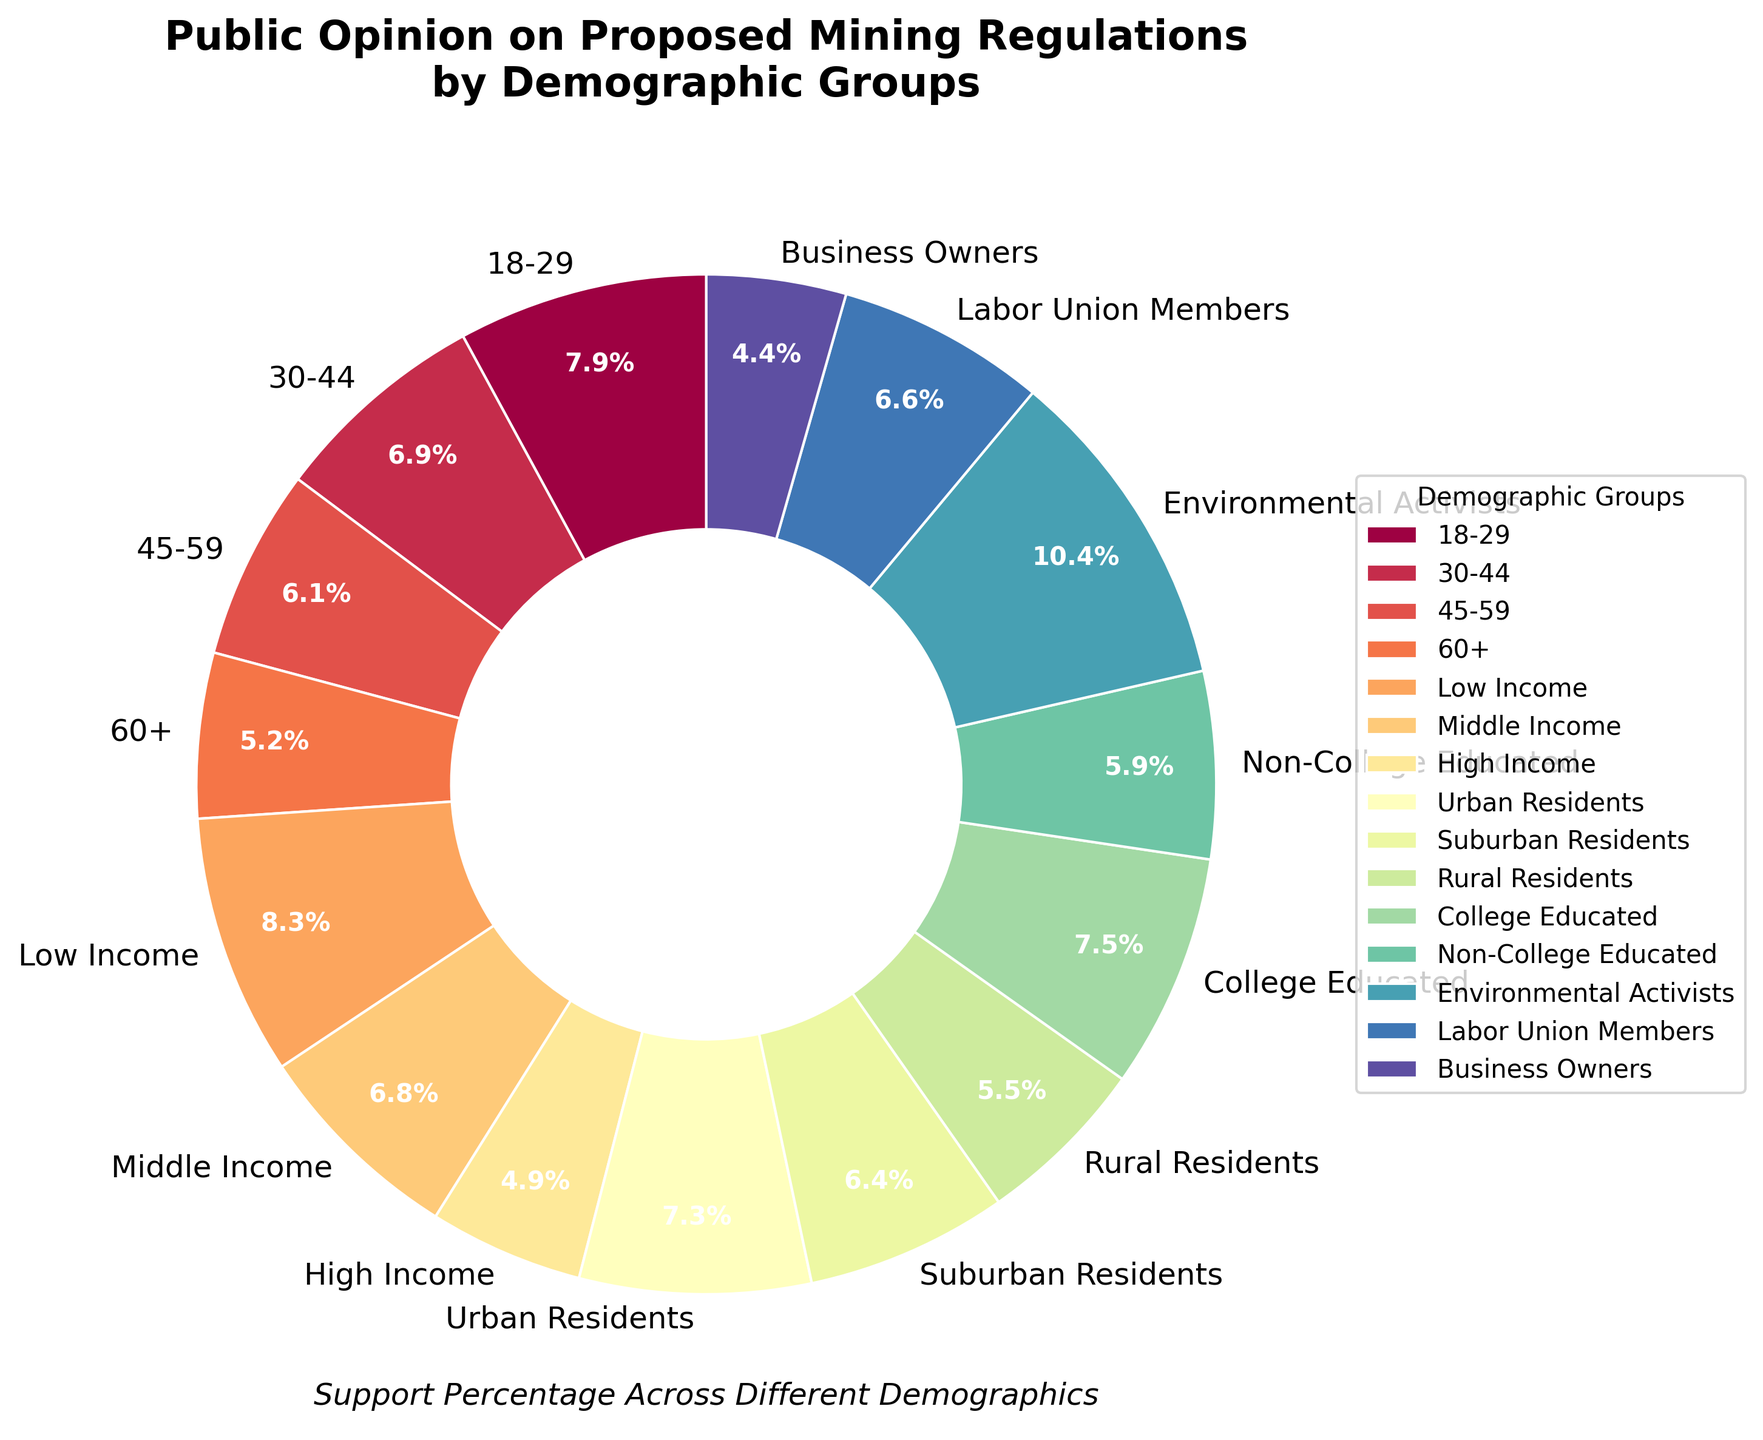What age group has the highest support percentage for the proposed mining regulations? The pie chart shows different age groups with support percentages for the proposed mining regulations. The 18-29 age group has the highest support percentage at 68%.
Answer: 18-29 Which demographic group has the lowest support percentage? By examining the various demographic groups in the pie chart, the Business Owners group has the lowest support percentage at 38%.
Answer: Business Owners What is the average support percentage among all demographic groups shown in the chart? To find the average, add the support percentages together and divide by the number of groups: (68 + 59 + 52 + 45 + 71 + 58 + 42 + 63 + 55 + 47 + 64 + 51 + 89 + 57 + 38) / 15. The sum is 819, and the average is 819/15 ≈ 54.6
Answer: 54.6 How does the support percentage of Urban Residents compare to that of Rural Residents? Compare the support percentages from the pie chart, where Urban Residents have 63% support and Rural Residents have 47%. 63% is greater than 47%.
Answer: Urban Residents have higher support What is the difference in support percentage between Environmental Activists and Business Owners? Subtract the support percentage of Business Owners from that of Environmental Activists: 89% - 38% = 51%.
Answer: 51% Which group has a support percentage closest to the overall average support percentage? The overall average is approximately 54.6%. The Middle Income group has a support percentage closest to this average at 58%.
Answer: Middle Income Does the support percentage of College Educated individuals exceed that of Non-College Educated individuals? The pie chart shows that College Educated individuals have 64% support, while Non-College Educated individuals have 51% support. 64% > 51%.
Answer: Yes Among the different income groups, which one shows the highest support percentage? Comparing the Low Income (71%), Middle Income (58%), and High Income (42%) support percentages, the Low Income group has the highest support percentage at 71%.
Answer: Low Income 